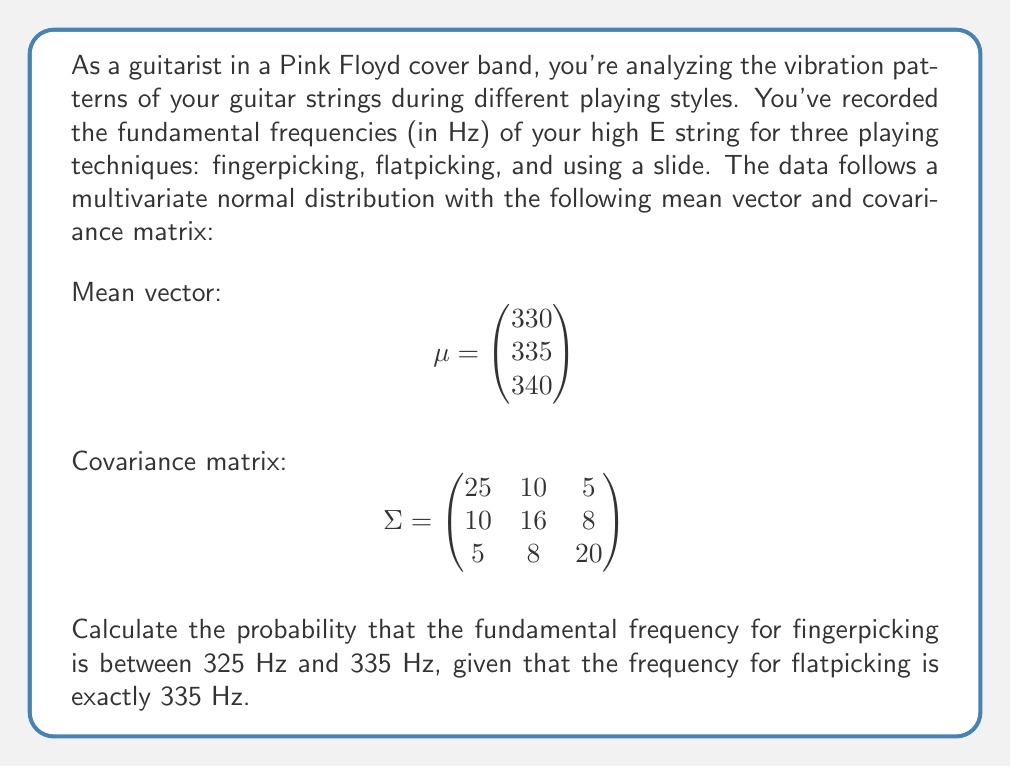What is the answer to this math problem? To solve this problem, we'll use conditional probability in multivariate normal distributions. Let's break it down step-by-step:

1) Let X₁ be the frequency for fingerpicking, X₂ for flatpicking, and X₃ for slide.

2) We need to find P(325 ≤ X₁ ≤ 335 | X₂ = 335)

3) In a multivariate normal distribution, the conditional distribution of X₁ given X₂ is also normal. We need to calculate its mean and variance.

4) The conditional mean is given by:
   $$\mu_{1|2} = \mu_1 + \frac{\sigma_{12}}{\sigma_{22}}(x_2 - \mu_2)$$
   
   $$\mu_{1|2} = 330 + \frac{10}{16}(335 - 335) = 330$$

5) The conditional variance is:
   $$\sigma_{1|2}^2 = \sigma_{11} - \frac{\sigma_{12}^2}{\sigma_{22}}$$
   
   $$\sigma_{1|2}^2 = 25 - \frac{10^2}{16} = 18.75$$

6) Now we have a normal distribution with μ = 330 and σ² = 18.75

7) We need to standardize our bounds:
   $$z_1 = \frac{325 - 330}{\sqrt{18.75}} = -1.155$$
   $$z_2 = \frac{335 - 330}{\sqrt{18.75}} = 1.155$$

8) The probability is the area between these z-scores:
   $$P(325 ≤ X₁ ≤ 335 | X₂ = 335) = \Phi(1.155) - \Phi(-1.155)$$

9) Using a standard normal table or calculator:
   $$= 0.8759 - 0.1241 = 0.7518$$

Therefore, the probability is approximately 0.7518 or 75.18%.
Answer: 0.7518 